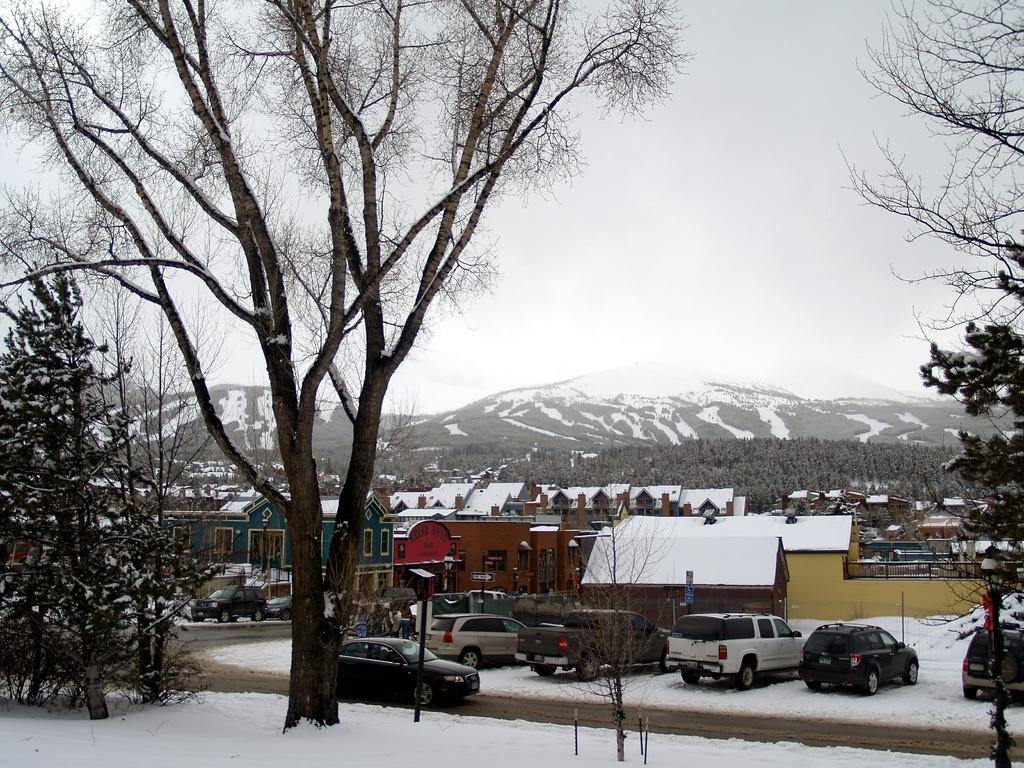What type of natural elements can be seen in the image? There are trees, plants, and mountains in the image. What type of man-made structures are present in the image? There are houses, buildings, and cars in the image. What is the condition of the mountains in the image? Snow is visible on the mountains in the image. What is the primary mode of transportation visible in the image? Cars are visible in the image. Can you tell me how many lamps are present in the image? There are no lamps visible in the image. Is there a fight happening between the trees in the image? There is no fight depicted in the image; it features trees, plants, houses, buildings, cars, mountains, and a road. What type of water body can be seen in the image? There is no water body, such as an ocean, present in the image. 